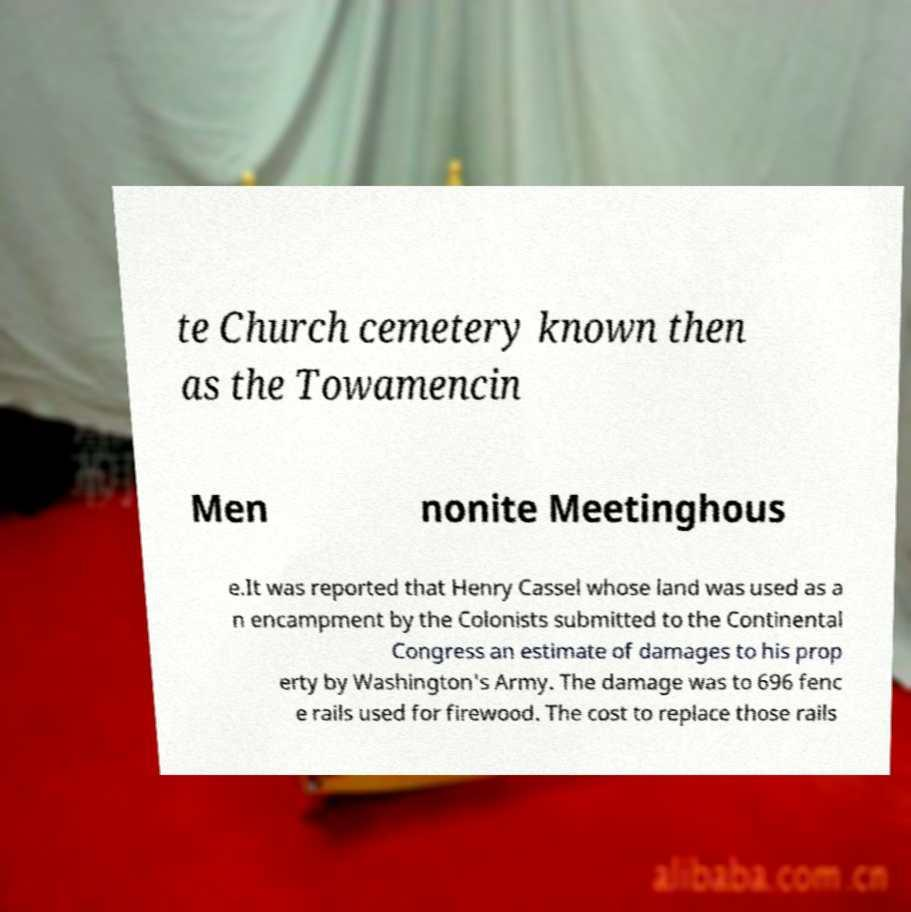I need the written content from this picture converted into text. Can you do that? te Church cemetery known then as the Towamencin Men nonite Meetinghous e.It was reported that Henry Cassel whose land was used as a n encampment by the Colonists submitted to the Continental Congress an estimate of damages to his prop erty by Washington's Army. The damage was to 696 fenc e rails used for firewood. The cost to replace those rails 